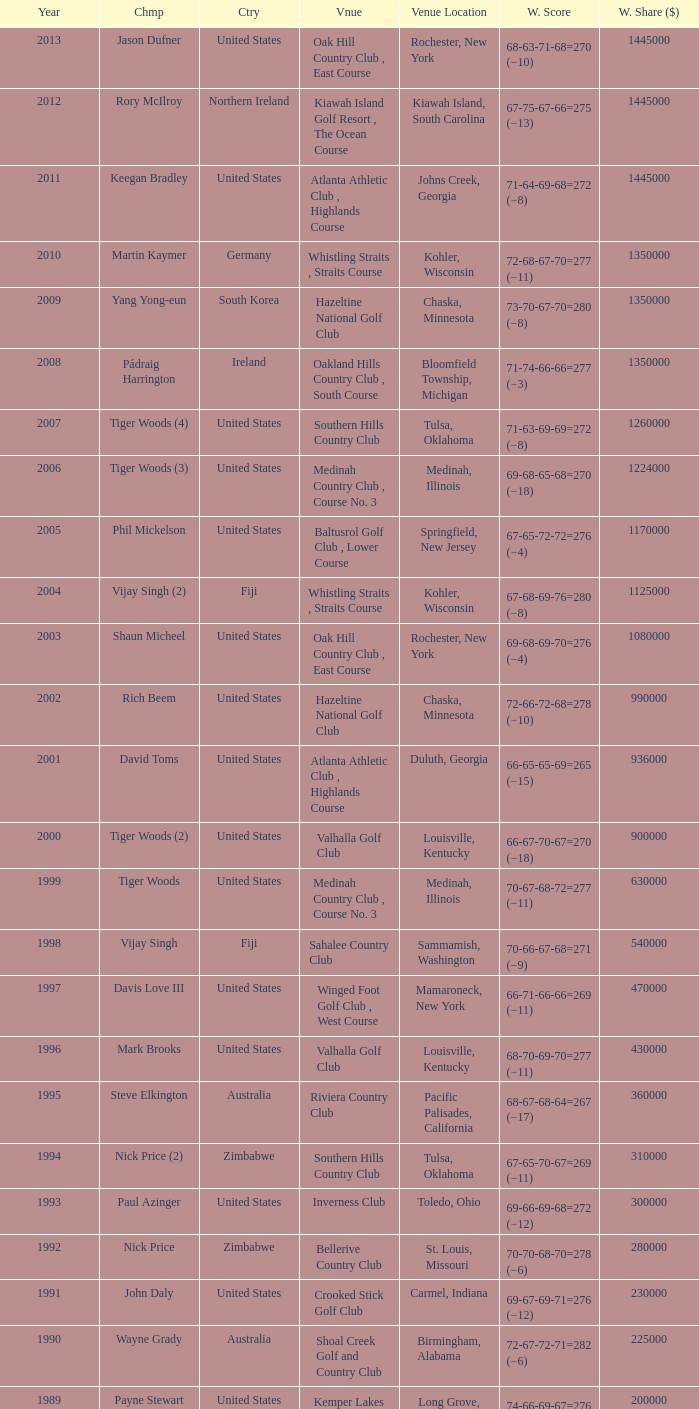Provide a list of all triumphant scores in 1982. 63-69-68-72=272 (−8). 